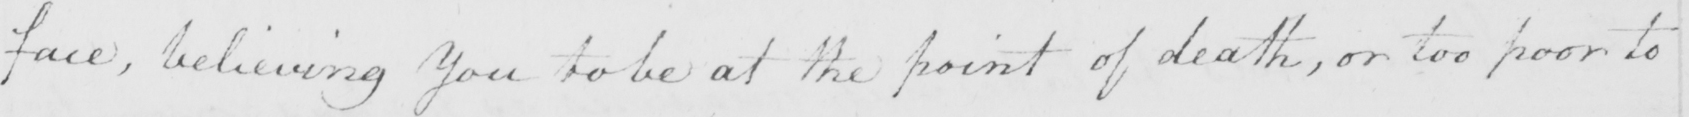Can you tell me what this handwritten text says? face , believing you to be at the point of death , or too poor to 